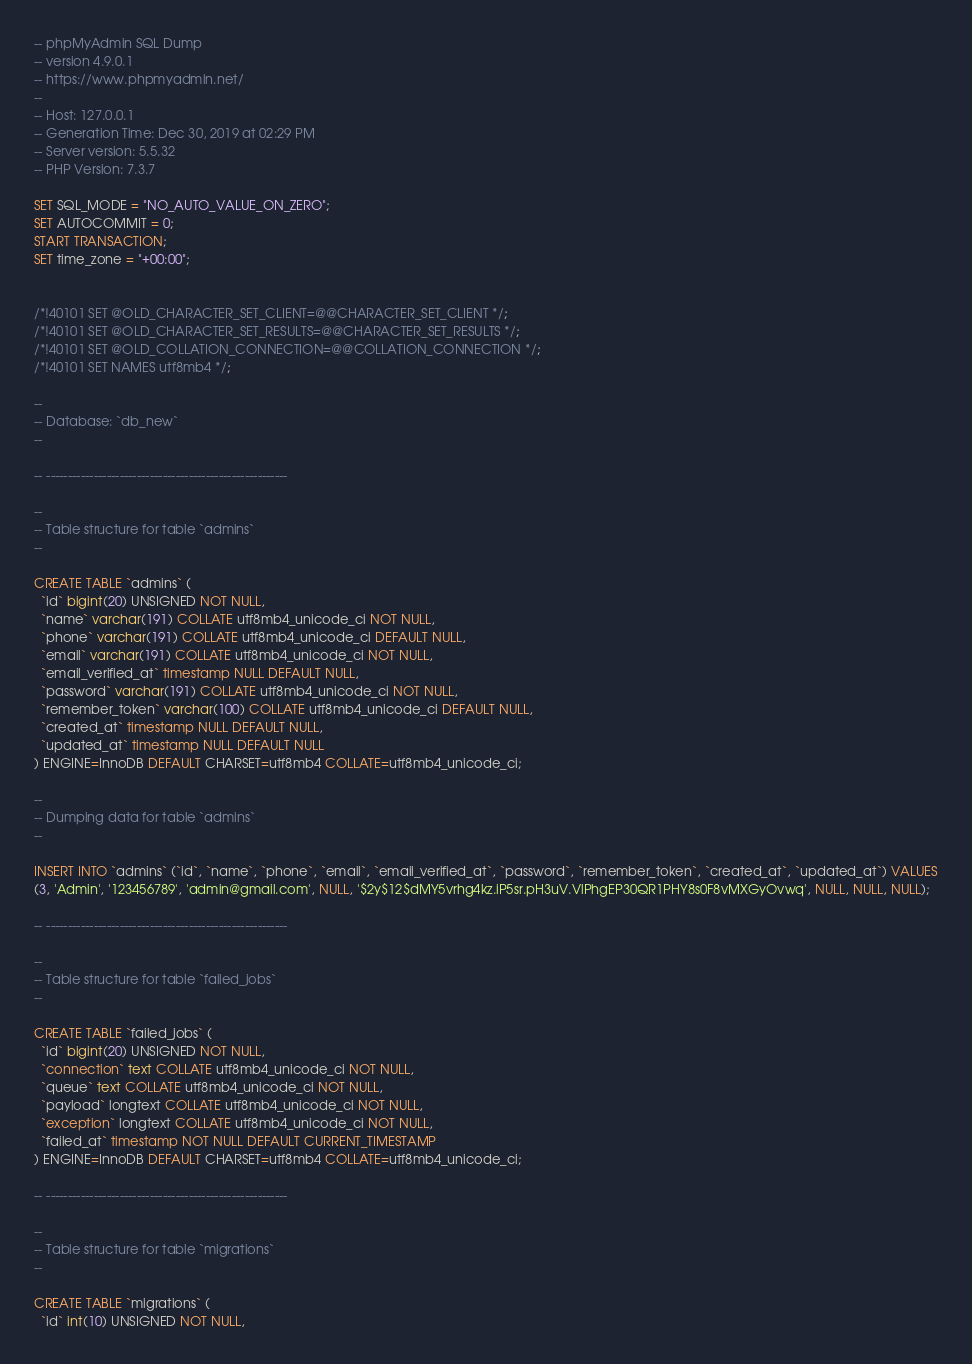<code> <loc_0><loc_0><loc_500><loc_500><_SQL_>-- phpMyAdmin SQL Dump
-- version 4.9.0.1
-- https://www.phpmyadmin.net/
--
-- Host: 127.0.0.1
-- Generation Time: Dec 30, 2019 at 02:29 PM
-- Server version: 5.5.32
-- PHP Version: 7.3.7

SET SQL_MODE = "NO_AUTO_VALUE_ON_ZERO";
SET AUTOCOMMIT = 0;
START TRANSACTION;
SET time_zone = "+00:00";


/*!40101 SET @OLD_CHARACTER_SET_CLIENT=@@CHARACTER_SET_CLIENT */;
/*!40101 SET @OLD_CHARACTER_SET_RESULTS=@@CHARACTER_SET_RESULTS */;
/*!40101 SET @OLD_COLLATION_CONNECTION=@@COLLATION_CONNECTION */;
/*!40101 SET NAMES utf8mb4 */;

--
-- Database: `db_new`
--

-- --------------------------------------------------------

--
-- Table structure for table `admins`
--

CREATE TABLE `admins` (
  `id` bigint(20) UNSIGNED NOT NULL,
  `name` varchar(191) COLLATE utf8mb4_unicode_ci NOT NULL,
  `phone` varchar(191) COLLATE utf8mb4_unicode_ci DEFAULT NULL,
  `email` varchar(191) COLLATE utf8mb4_unicode_ci NOT NULL,
  `email_verified_at` timestamp NULL DEFAULT NULL,
  `password` varchar(191) COLLATE utf8mb4_unicode_ci NOT NULL,
  `remember_token` varchar(100) COLLATE utf8mb4_unicode_ci DEFAULT NULL,
  `created_at` timestamp NULL DEFAULT NULL,
  `updated_at` timestamp NULL DEFAULT NULL
) ENGINE=InnoDB DEFAULT CHARSET=utf8mb4 COLLATE=utf8mb4_unicode_ci;

--
-- Dumping data for table `admins`
--

INSERT INTO `admins` (`id`, `name`, `phone`, `email`, `email_verified_at`, `password`, `remember_token`, `created_at`, `updated_at`) VALUES
(3, 'Admin', '123456789', 'admin@gmail.com', NULL, '$2y$12$dMY5vrhg4kz.iP5sr.pH3uV.VlPhgEP30QR1PHY8s0F8vMXGyOvwq', NULL, NULL, NULL);

-- --------------------------------------------------------

--
-- Table structure for table `failed_jobs`
--

CREATE TABLE `failed_jobs` (
  `id` bigint(20) UNSIGNED NOT NULL,
  `connection` text COLLATE utf8mb4_unicode_ci NOT NULL,
  `queue` text COLLATE utf8mb4_unicode_ci NOT NULL,
  `payload` longtext COLLATE utf8mb4_unicode_ci NOT NULL,
  `exception` longtext COLLATE utf8mb4_unicode_ci NOT NULL,
  `failed_at` timestamp NOT NULL DEFAULT CURRENT_TIMESTAMP
) ENGINE=InnoDB DEFAULT CHARSET=utf8mb4 COLLATE=utf8mb4_unicode_ci;

-- --------------------------------------------------------

--
-- Table structure for table `migrations`
--

CREATE TABLE `migrations` (
  `id` int(10) UNSIGNED NOT NULL,</code> 